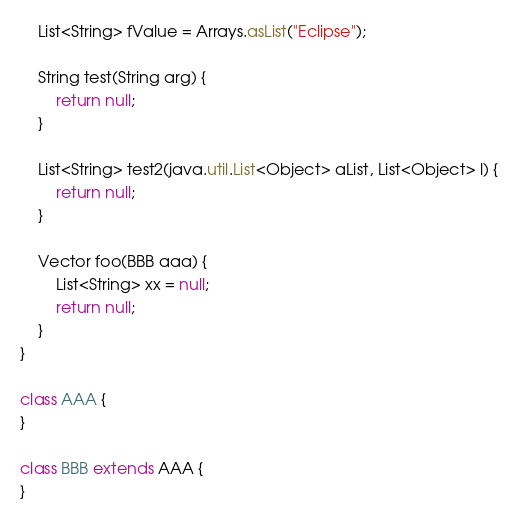<code> <loc_0><loc_0><loc_500><loc_500><_Java_>    List<String> fValue = Arrays.asList("Eclipse");

    String test(String arg) {
        return null;
    }

    List<String> test2(java.util.List<Object> aList, List<Object> l) {
        return null;
    }

    Vector foo(BBB aaa) {
        List<String> xx = null;
        return null;
    }
}

class AAA {
}

class BBB extends AAA {
}
</code> 